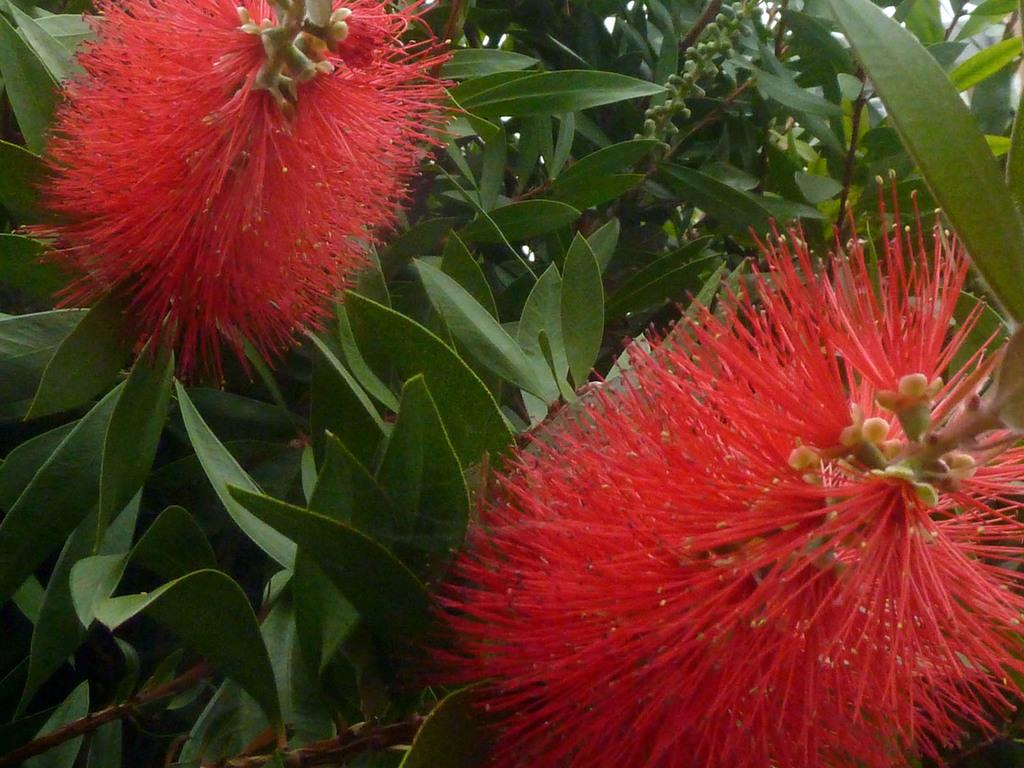What type of living organisms can be seen in the image? There are flowers and plants in the image. Can you describe the flowers in the image? Unfortunately, the facts provided do not give specific details about the flowers. What is the relationship between the flowers and plants in the image? Both flowers and plants are types of vegetation, and they may be growing together in the image. What type of baseball equipment is visible in the image? There is no baseball equipment present in the image. What thought process is the queen going through in the image? There is no queen or thought process depicted in the image. 